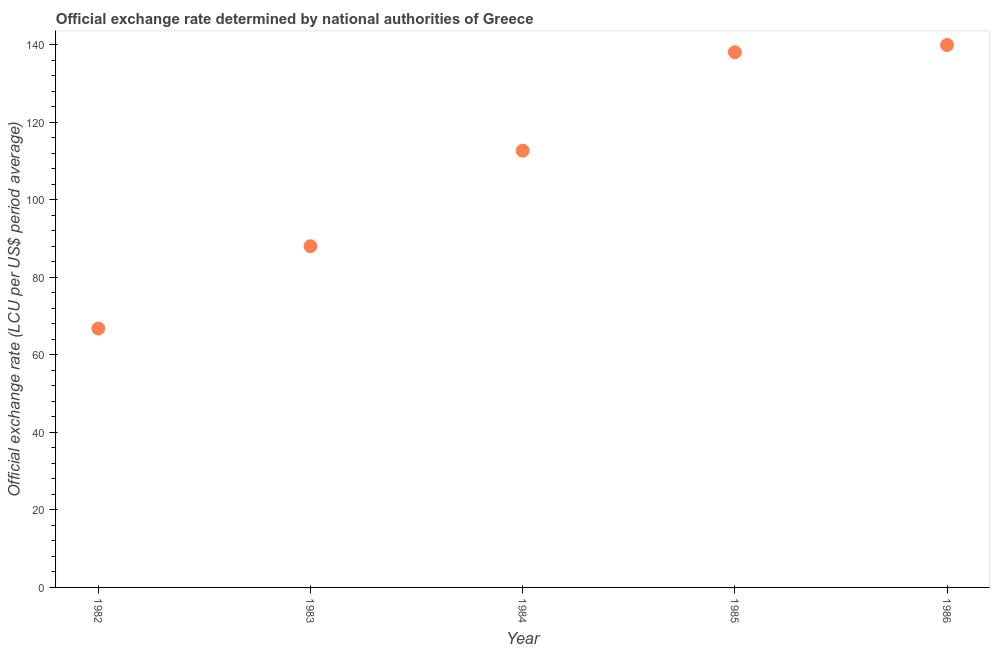What is the official exchange rate in 1984?
Offer a terse response. 112.72. Across all years, what is the maximum official exchange rate?
Give a very brief answer. 139.98. Across all years, what is the minimum official exchange rate?
Provide a succinct answer. 66.8. In which year was the official exchange rate maximum?
Offer a terse response. 1986. What is the sum of the official exchange rate?
Your answer should be very brief. 545.68. What is the difference between the official exchange rate in 1984 and 1985?
Make the answer very short. -25.4. What is the average official exchange rate per year?
Provide a succinct answer. 109.14. What is the median official exchange rate?
Ensure brevity in your answer.  112.72. In how many years, is the official exchange rate greater than 128 ?
Provide a short and direct response. 2. What is the ratio of the official exchange rate in 1983 to that in 1984?
Keep it short and to the point. 0.78. What is the difference between the highest and the second highest official exchange rate?
Your answer should be very brief. 1.86. Is the sum of the official exchange rate in 1985 and 1986 greater than the maximum official exchange rate across all years?
Offer a very short reply. Yes. What is the difference between the highest and the lowest official exchange rate?
Ensure brevity in your answer.  73.18. How many years are there in the graph?
Give a very brief answer. 5. What is the difference between two consecutive major ticks on the Y-axis?
Offer a terse response. 20. Are the values on the major ticks of Y-axis written in scientific E-notation?
Your answer should be compact. No. What is the title of the graph?
Give a very brief answer. Official exchange rate determined by national authorities of Greece. What is the label or title of the Y-axis?
Keep it short and to the point. Official exchange rate (LCU per US$ period average). What is the Official exchange rate (LCU per US$ period average) in 1982?
Offer a terse response. 66.8. What is the Official exchange rate (LCU per US$ period average) in 1983?
Make the answer very short. 88.06. What is the Official exchange rate (LCU per US$ period average) in 1984?
Your response must be concise. 112.72. What is the Official exchange rate (LCU per US$ period average) in 1985?
Give a very brief answer. 138.12. What is the Official exchange rate (LCU per US$ period average) in 1986?
Offer a terse response. 139.98. What is the difference between the Official exchange rate (LCU per US$ period average) in 1982 and 1983?
Your response must be concise. -21.26. What is the difference between the Official exchange rate (LCU per US$ period average) in 1982 and 1984?
Offer a terse response. -45.91. What is the difference between the Official exchange rate (LCU per US$ period average) in 1982 and 1985?
Provide a short and direct response. -71.32. What is the difference between the Official exchange rate (LCU per US$ period average) in 1982 and 1986?
Give a very brief answer. -73.18. What is the difference between the Official exchange rate (LCU per US$ period average) in 1983 and 1984?
Provide a short and direct response. -24.65. What is the difference between the Official exchange rate (LCU per US$ period average) in 1983 and 1985?
Provide a short and direct response. -50.05. What is the difference between the Official exchange rate (LCU per US$ period average) in 1983 and 1986?
Offer a terse response. -51.92. What is the difference between the Official exchange rate (LCU per US$ period average) in 1984 and 1985?
Provide a succinct answer. -25.4. What is the difference between the Official exchange rate (LCU per US$ period average) in 1984 and 1986?
Provide a short and direct response. -27.26. What is the difference between the Official exchange rate (LCU per US$ period average) in 1985 and 1986?
Ensure brevity in your answer.  -1.86. What is the ratio of the Official exchange rate (LCU per US$ period average) in 1982 to that in 1983?
Ensure brevity in your answer.  0.76. What is the ratio of the Official exchange rate (LCU per US$ period average) in 1982 to that in 1984?
Give a very brief answer. 0.59. What is the ratio of the Official exchange rate (LCU per US$ period average) in 1982 to that in 1985?
Offer a very short reply. 0.48. What is the ratio of the Official exchange rate (LCU per US$ period average) in 1982 to that in 1986?
Offer a terse response. 0.48. What is the ratio of the Official exchange rate (LCU per US$ period average) in 1983 to that in 1984?
Your answer should be very brief. 0.78. What is the ratio of the Official exchange rate (LCU per US$ period average) in 1983 to that in 1985?
Make the answer very short. 0.64. What is the ratio of the Official exchange rate (LCU per US$ period average) in 1983 to that in 1986?
Your answer should be compact. 0.63. What is the ratio of the Official exchange rate (LCU per US$ period average) in 1984 to that in 1985?
Ensure brevity in your answer.  0.82. What is the ratio of the Official exchange rate (LCU per US$ period average) in 1984 to that in 1986?
Provide a succinct answer. 0.81. 